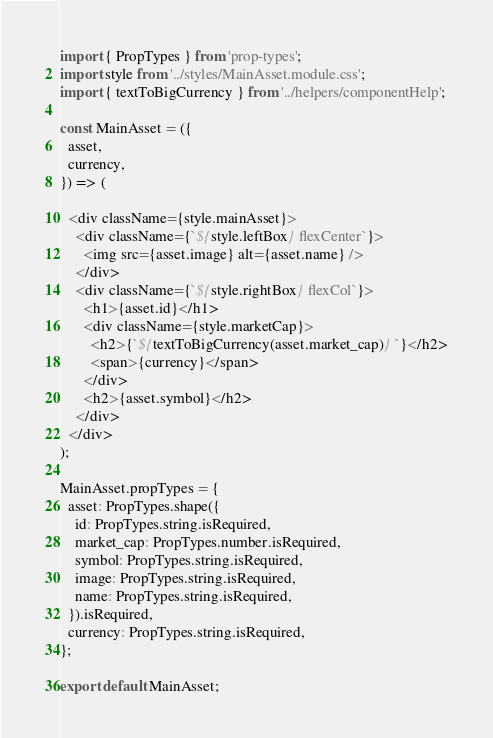<code> <loc_0><loc_0><loc_500><loc_500><_JavaScript_>import { PropTypes } from 'prop-types';
import style from '../styles/MainAsset.module.css';
import { textToBigCurrency } from '../helpers/componentHelp';

const MainAsset = ({
  asset,
  currency,
}) => (

  <div className={style.mainAsset}>
    <div className={`${style.leftBox} flexCenter`}>
      <img src={asset.image} alt={asset.name} />
    </div>
    <div className={`${style.rightBox} flexCol`}>
      <h1>{asset.id}</h1>
      <div className={style.marketCap}>
        <h2>{`${textToBigCurrency(asset.market_cap)} `}</h2>
        <span>{currency}</span>
      </div>
      <h2>{asset.symbol}</h2>
    </div>
  </div>
);

MainAsset.propTypes = {
  asset: PropTypes.shape({
    id: PropTypes.string.isRequired,
    market_cap: PropTypes.number.isRequired,
    symbol: PropTypes.string.isRequired,
    image: PropTypes.string.isRequired,
    name: PropTypes.string.isRequired,
  }).isRequired,
  currency: PropTypes.string.isRequired,
};

export default MainAsset;
</code> 